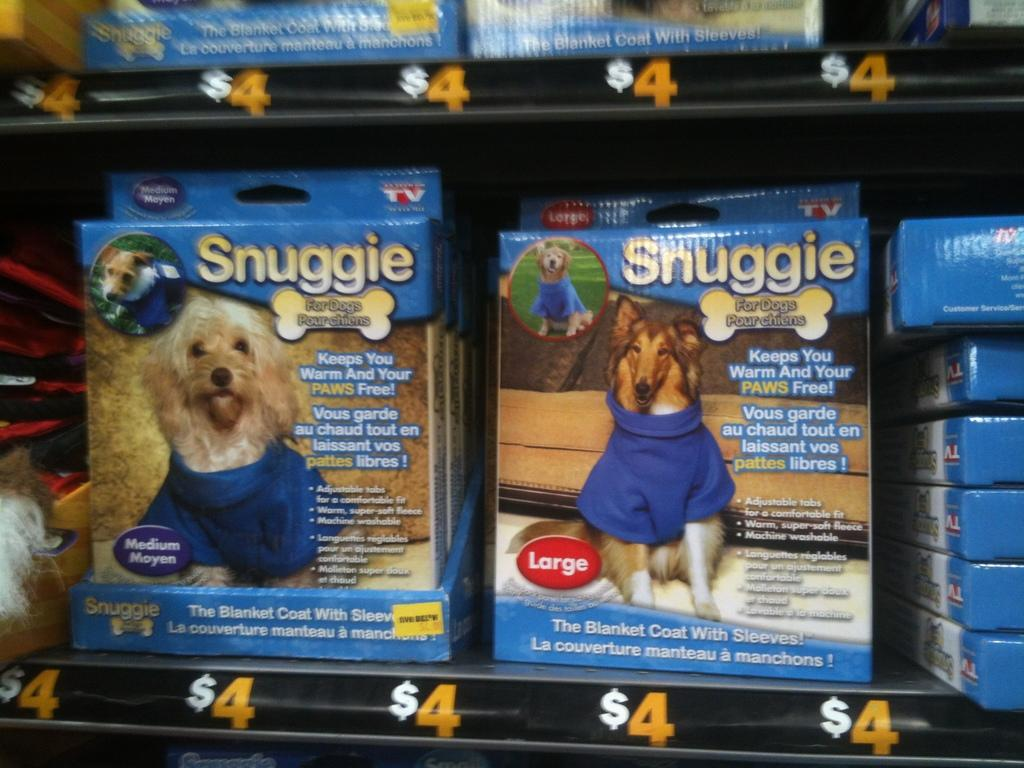Where was the image taken? The image was taken indoors. What can be seen on the shelves in the image? There are many boxes on the shelves in the image. What type of images are present in the image? There are images of dogs in the image. What information is provided on the boxes? There is text on the boxes. What type of magic is being performed by the dogs in the image? There are no dogs performing magic in the image; the image only contains images of dogs. How do the plants in the image affect the temper of the person taking the photo? There are no plants present in the image, so their effect on the temper of the person taking the photo cannot be determined. 